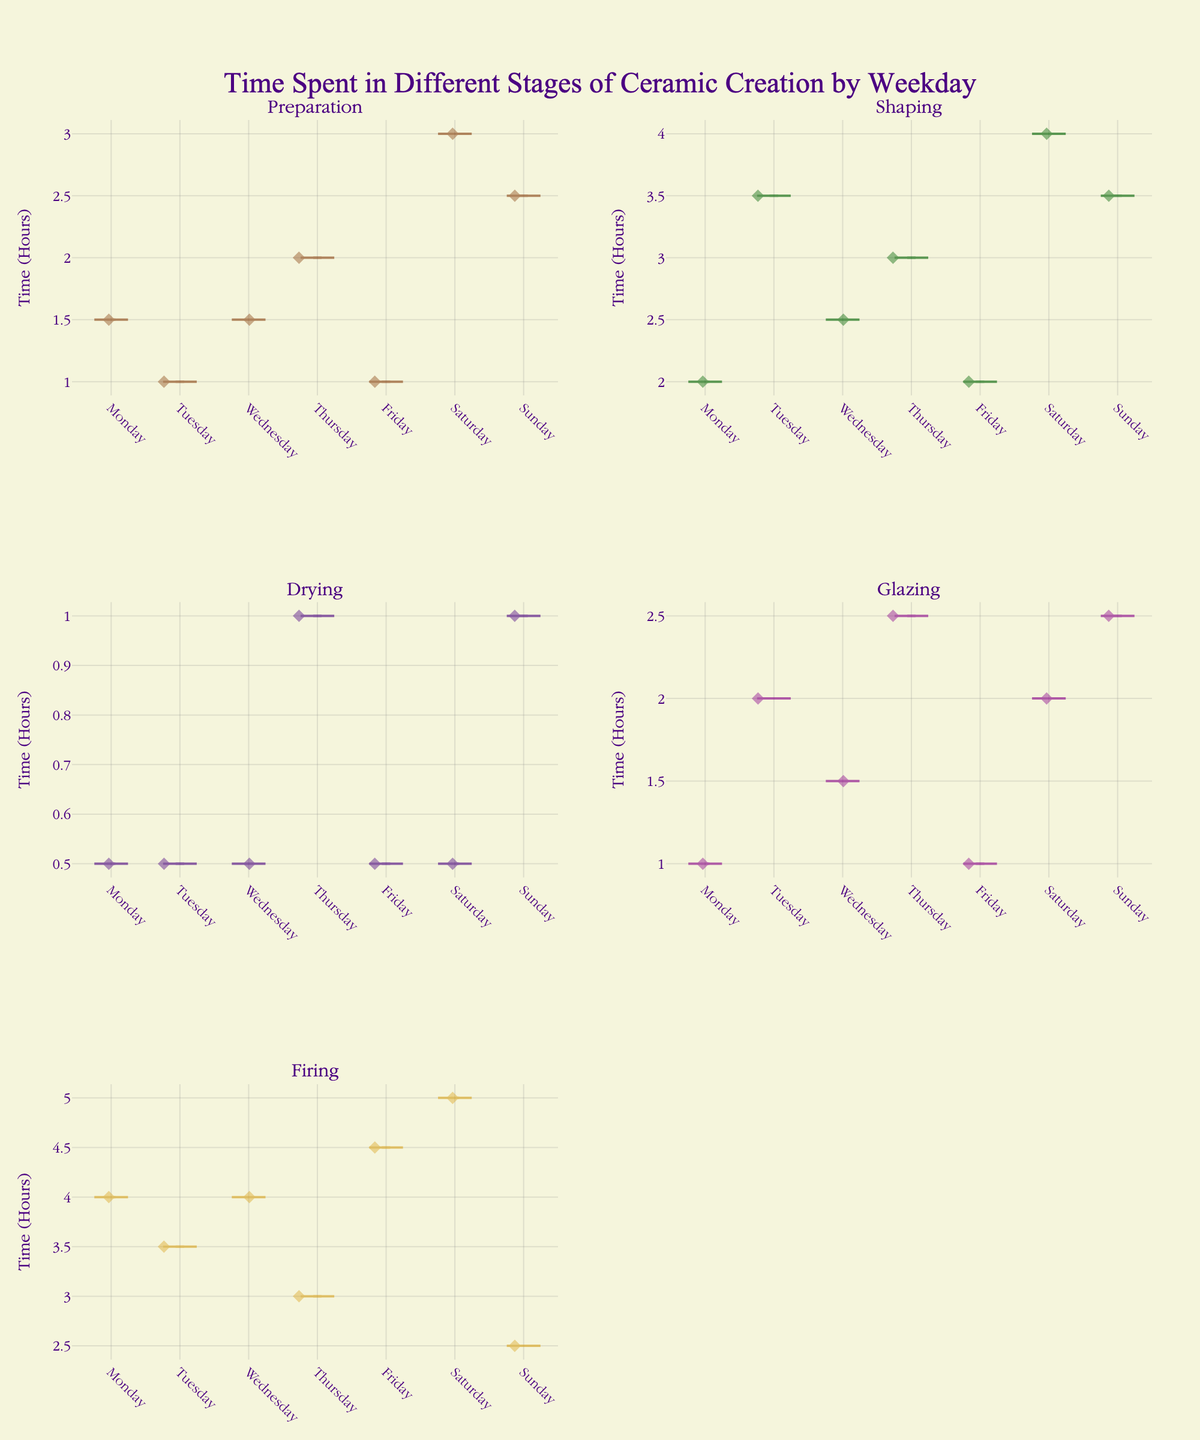How many stages are plotted in the figure? Count the number of subplot titles to determine the number of stages plotted.
Answer: 5 stages What day shows the maximum time spent on Firing? Look at the "Firing" subplot and identify the day with the highest point, which represents the maximum time spent.
Answer: Saturday Which stage has the most varied time spent throughout the week? Compare the range of the violin plots for each stage to see which has the widest spread of data points.
Answer: Shaping Which day seems to have the least time spent on Preparation? Check the "Preparation" subplot to find the day with the lowest point, representing the least time spent.
Answer: Friday On which days is the Glazing stage most consistent with its time spent? Identify the days in the "Glazing" subplot where the violin plot is the narrowest, indicating less variability.
Answer: Monday and Wednesday What is the median time spent on Shaping for Saturday? Look at the box plot within the "Shaping" violin plot for Saturday and identify the line that represents the median.
Answer: 4.0 hours Does any stage have days with zero time spent? Examine each violin plot to see if any have days with no points, indicating zero time spent.
Answer: No How does the time spent on Drying generally compare throughout the week? Review the overall spread and median lines of the "Drying" violin plot for each day of the week.
Answer: Fairly consistent with a median of 0.5 or 1.0 hours Which stage has the largest maximum time spent overall? Evaluate each stage's violin plot and identify the one with the highest single data point.
Answer: Firing Is there a day where the time spent on Preparation exceeds 2 hours? If so, which day(s)? Look at the "Preparation" subplot and identify any days where points are above the 2-hour mark.
Answer: Saturday and Sunday 